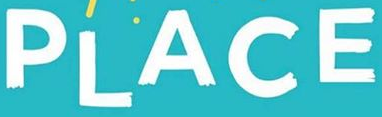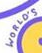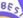What text appears in these images from left to right, separated by a semicolon? PLACE; WORLO'S; BES 